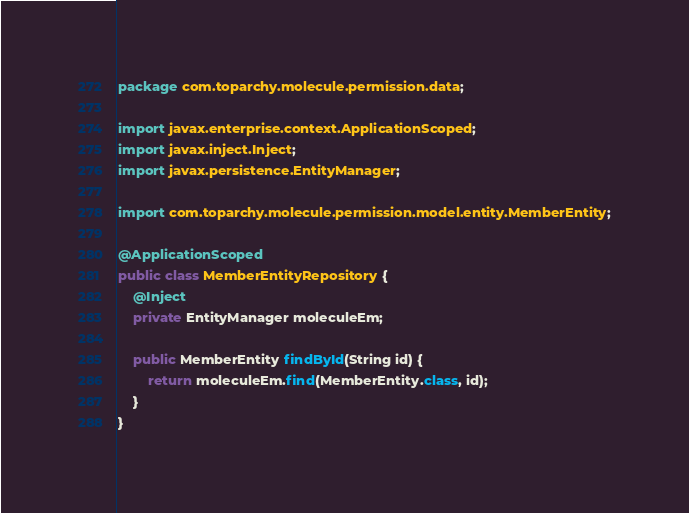Convert code to text. <code><loc_0><loc_0><loc_500><loc_500><_Java_>package com.toparchy.molecule.permission.data;

import javax.enterprise.context.ApplicationScoped;
import javax.inject.Inject;
import javax.persistence.EntityManager;

import com.toparchy.molecule.permission.model.entity.MemberEntity;

@ApplicationScoped
public class MemberEntityRepository {
	@Inject
	private EntityManager moleculeEm;

	public MemberEntity findById(String id) {
		return moleculeEm.find(MemberEntity.class, id);
	}
}
</code> 